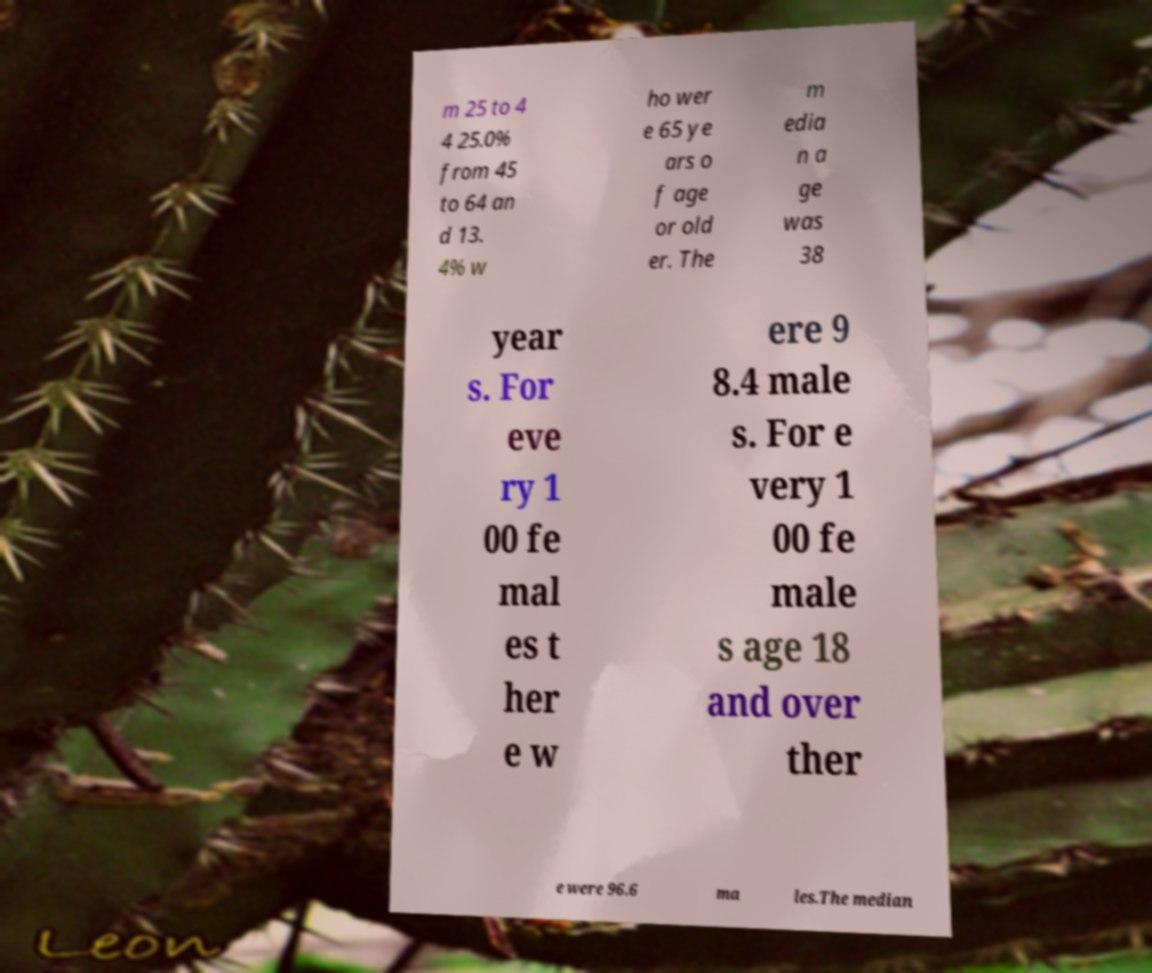What messages or text are displayed in this image? I need them in a readable, typed format. m 25 to 4 4 25.0% from 45 to 64 an d 13. 4% w ho wer e 65 ye ars o f age or old er. The m edia n a ge was 38 year s. For eve ry 1 00 fe mal es t her e w ere 9 8.4 male s. For e very 1 00 fe male s age 18 and over ther e were 96.6 ma les.The median 